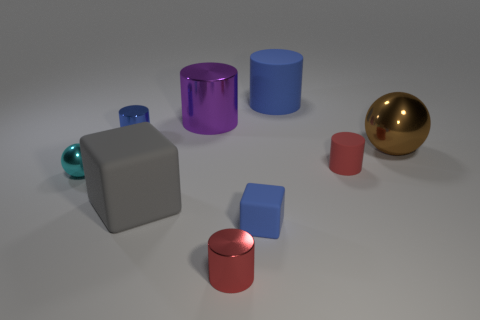Subtract 2 cylinders. How many cylinders are left? 3 Subtract all purple cylinders. How many cylinders are left? 4 Subtract all red shiny cylinders. How many cylinders are left? 4 Subtract all small blue cubes. Subtract all matte things. How many objects are left? 4 Add 8 purple cylinders. How many purple cylinders are left? 9 Add 6 brown metal cylinders. How many brown metal cylinders exist? 6 Subtract 0 yellow cylinders. How many objects are left? 9 Subtract all blocks. How many objects are left? 7 Subtract all cyan cylinders. Subtract all purple cubes. How many cylinders are left? 5 